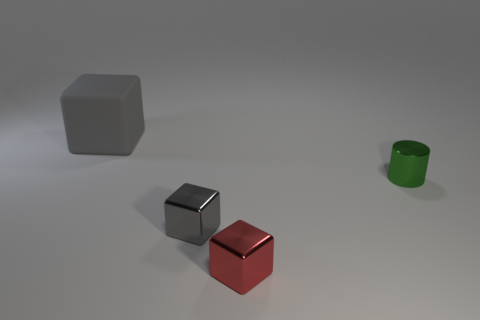Are there any other things that are the same size as the rubber block?
Your answer should be compact. No. There is a green shiny cylinder; how many small cylinders are in front of it?
Ensure brevity in your answer.  0. What is the material of the big cube?
Your answer should be very brief. Rubber. Is the number of gray metallic objects that are behind the tiny green metal cylinder less than the number of large brown spheres?
Ensure brevity in your answer.  No. The block behind the green thing is what color?
Ensure brevity in your answer.  Gray. What is the shape of the red metal object?
Your response must be concise. Cube. Are there any tiny cylinders in front of the small metal object that is in front of the gray thing that is in front of the large gray matte cube?
Your response must be concise. No. There is a object that is behind the tiny object behind the gray thing that is right of the large gray block; what is its color?
Your response must be concise. Gray. What material is the large gray thing that is the same shape as the small red metal thing?
Make the answer very short. Rubber. There is a metallic object that is in front of the gray object in front of the big gray rubber block; how big is it?
Keep it short and to the point. Small. 